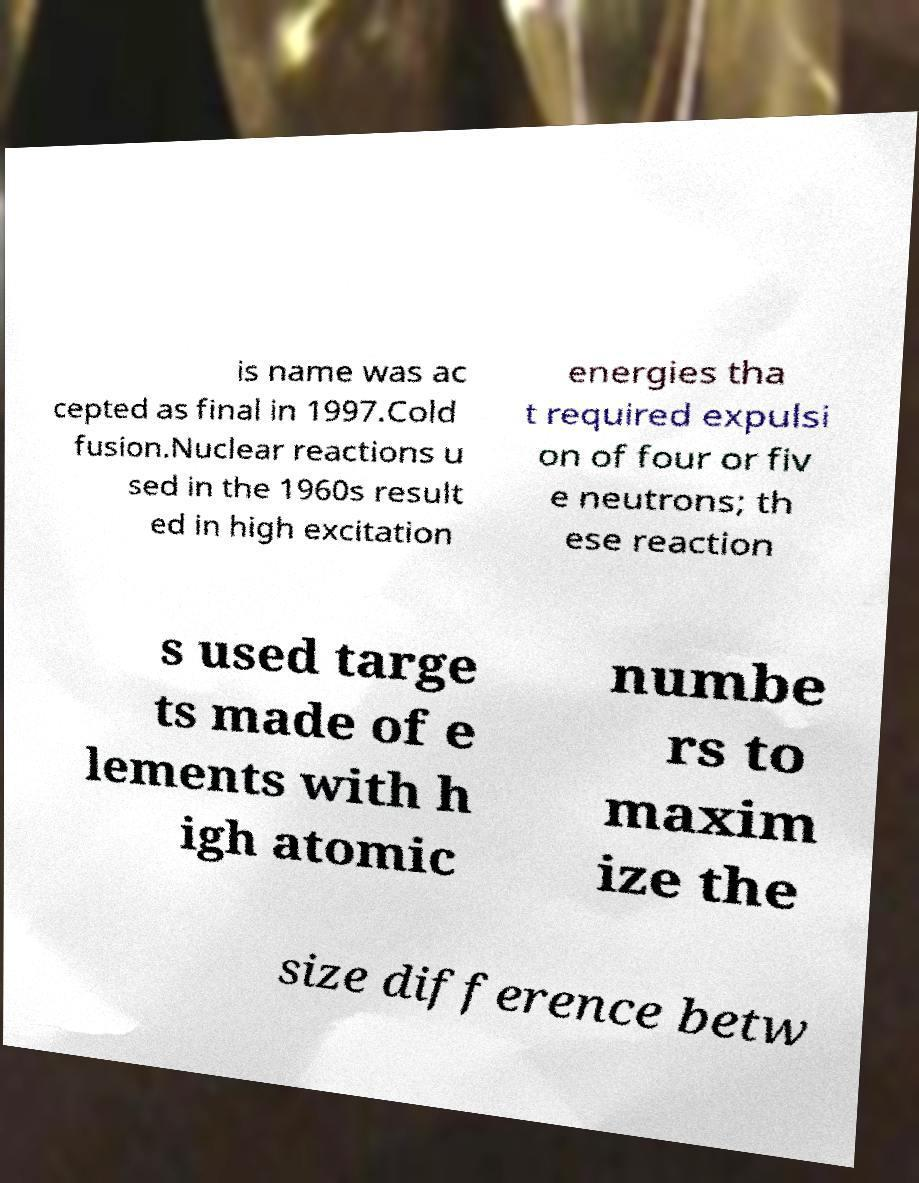For documentation purposes, I need the text within this image transcribed. Could you provide that? is name was ac cepted as final in 1997.Cold fusion.Nuclear reactions u sed in the 1960s result ed in high excitation energies tha t required expulsi on of four or fiv e neutrons; th ese reaction s used targe ts made of e lements with h igh atomic numbe rs to maxim ize the size difference betw 